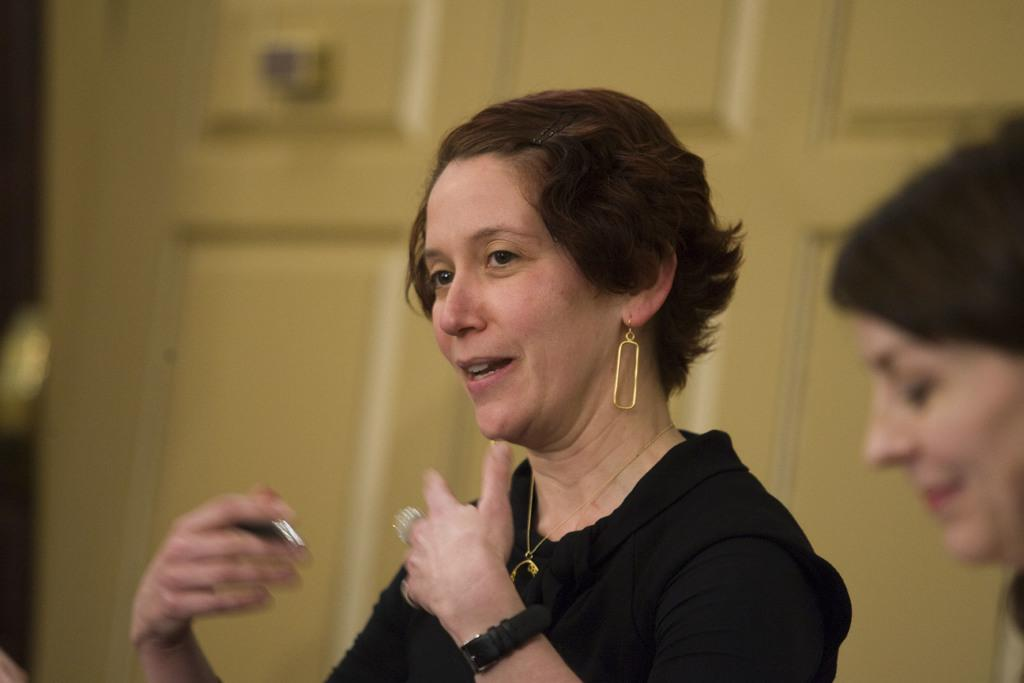What is the woman in the image doing? There is a woman sitting and talking in the image. What is the woman wearing? The woman is wearing a black dress. Can you describe the other woman in the image? There is another woman with a smiling face in the image. What is visible behind the two women? There is a door visible behind the two women. What is the weight of the airplane flying over the stream in the image? There is no airplane or stream present in the image; it only features two women talking and a door in the background. 